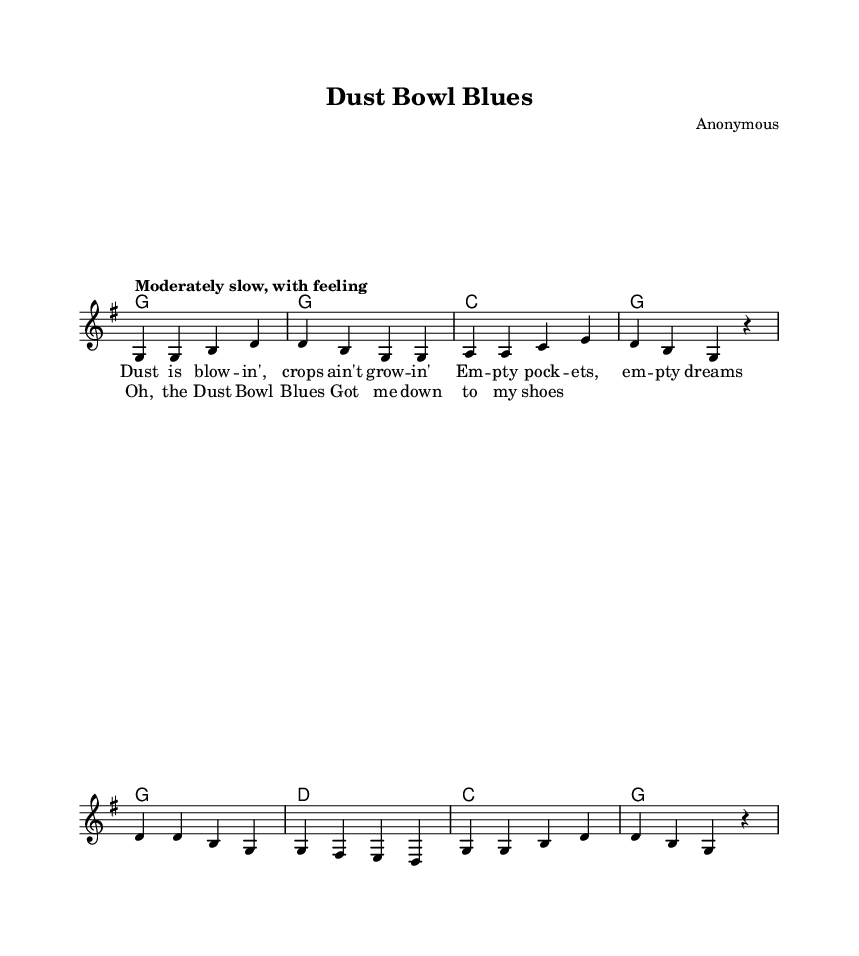What is the key signature of this music? The key signature is G major, which has one sharp (F#). You can determine this by looking at the beginning of the sheet music where the key signature is indicated.
Answer: G major What is the time signature of this music? The time signature is 4/4, indicated at the beginning of the score. This means there are four beats in each measure and a quarter note receives one beat.
Answer: 4/4 What is the tempo marking for this piece? The tempo marking is "Moderately slow, with feeling." It is shown just above the staff, indicating how the piece should be played in terms of speed.
Answer: Moderately slow, with feeling How many measures are in the verse? The verse consists of four measures. By counting the groups of notes separated by vertical lines on the sheet music, you can confirm there are four segments or measures labeled as the verse.
Answer: Four What are the last two lines of the chorus lyrics? The last two lines of the chorus lyrics are "Got me down to my shoes." You can find these lyrics noted under the corresponding melody in the sheet music.
Answer: Got me down to my shoes How does the harmony change between the verse and the chorus? In the verse, the harmony follows a pattern of G, G, C, G, while in the chorus, it transitions to G, D, C, G. This shows a change from a more stable harmony in the verse to a slight variation in the chorus.
Answer: G, D, C, G 